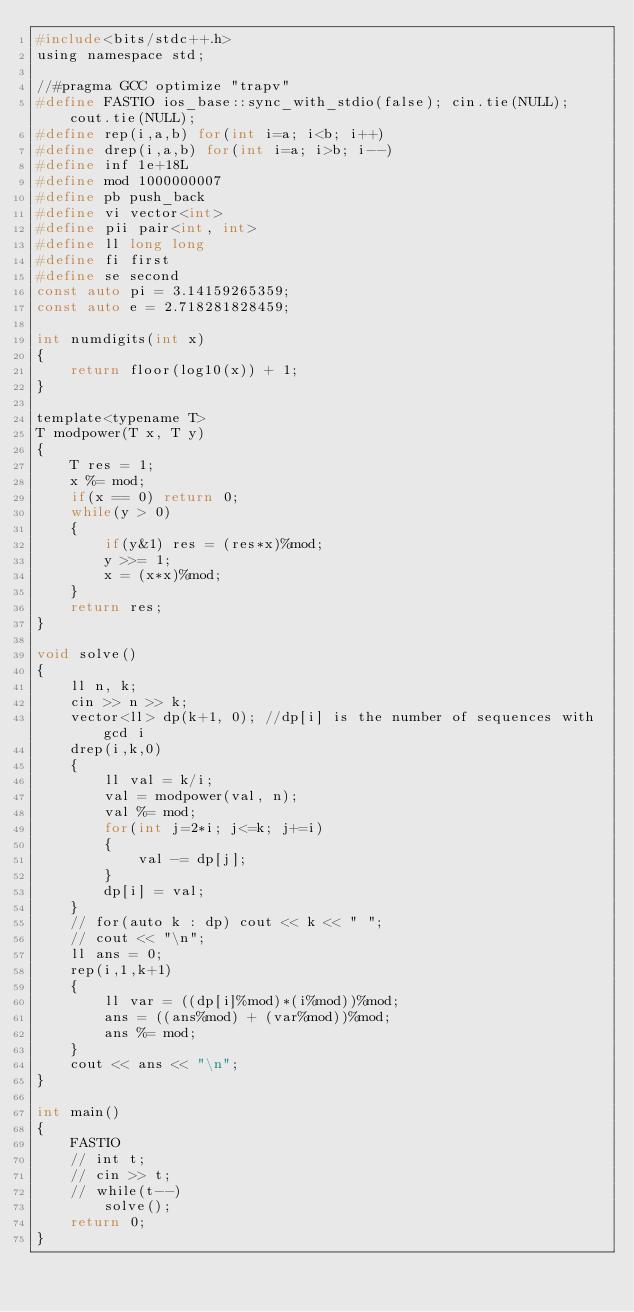Convert code to text. <code><loc_0><loc_0><loc_500><loc_500><_C_>#include<bits/stdc++.h>
using namespace std;

//#pragma GCC optimize "trapv"
#define FASTIO ios_base::sync_with_stdio(false); cin.tie(NULL); cout.tie(NULL);
#define rep(i,a,b) for(int i=a; i<b; i++)
#define drep(i,a,b) for(int i=a; i>b; i--)
#define inf 1e+18L
#define mod 1000000007
#define pb push_back
#define vi vector<int>
#define pii pair<int, int>
#define ll long long 
#define fi first
#define se second
const auto pi = 3.14159265359;
const auto e = 2.718281828459;

int numdigits(int x)
{
    return floor(log10(x)) + 1;
}

template<typename T>
T modpower(T x, T y)
{
    T res = 1;
    x %= mod;
    if(x == 0) return 0;
    while(y > 0)
    {
        if(y&1) res = (res*x)%mod;
        y >>= 1;
        x = (x*x)%mod;
    }
    return res;
}

void solve()
{
    ll n, k;
    cin >> n >> k;
    vector<ll> dp(k+1, 0); //dp[i] is the number of sequences with gcd i
    drep(i,k,0)
    {
        ll val = k/i;
        val = modpower(val, n);
        val %= mod;
        for(int j=2*i; j<=k; j+=i)
        {
            val -= dp[j];
        }
        dp[i] = val;
    }
    // for(auto k : dp) cout << k << " ";
    // cout << "\n";
    ll ans = 0;
    rep(i,1,k+1)
    {
        ll var = ((dp[i]%mod)*(i%mod))%mod;
        ans = ((ans%mod) + (var%mod))%mod;
        ans %= mod;
    }
    cout << ans << "\n";
}

int main()
{
    FASTIO
    // int t;
    // cin >> t;
    // while(t--)
        solve();
    return 0;
}</code> 